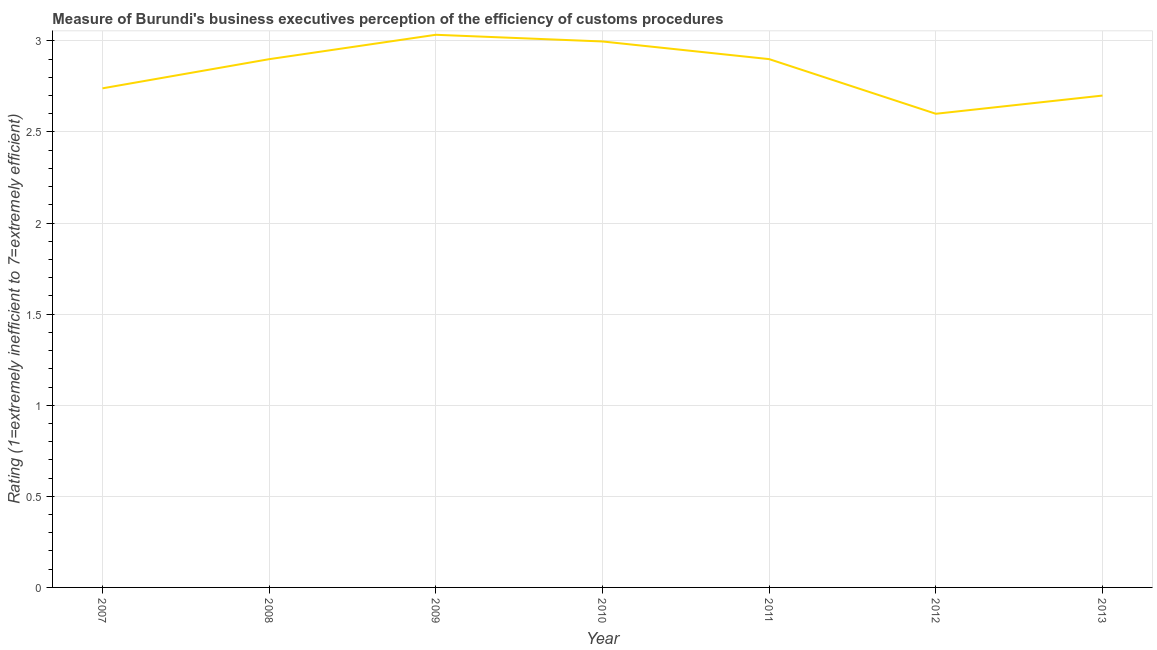Across all years, what is the maximum rating measuring burden of customs procedure?
Your response must be concise. 3.03. In which year was the rating measuring burden of customs procedure maximum?
Give a very brief answer. 2009. In which year was the rating measuring burden of customs procedure minimum?
Give a very brief answer. 2012. What is the sum of the rating measuring burden of customs procedure?
Provide a short and direct response. 19.87. What is the difference between the rating measuring burden of customs procedure in 2010 and 2012?
Ensure brevity in your answer.  0.4. What is the average rating measuring burden of customs procedure per year?
Ensure brevity in your answer.  2.84. What is the median rating measuring burden of customs procedure?
Offer a terse response. 2.9. In how many years, is the rating measuring burden of customs procedure greater than 1.7 ?
Make the answer very short. 7. What is the ratio of the rating measuring burden of customs procedure in 2011 to that in 2013?
Keep it short and to the point. 1.07. Is the difference between the rating measuring burden of customs procedure in 2009 and 2012 greater than the difference between any two years?
Provide a short and direct response. Yes. What is the difference between the highest and the second highest rating measuring burden of customs procedure?
Give a very brief answer. 0.04. Is the sum of the rating measuring burden of customs procedure in 2011 and 2012 greater than the maximum rating measuring burden of customs procedure across all years?
Your answer should be compact. Yes. What is the difference between the highest and the lowest rating measuring burden of customs procedure?
Your response must be concise. 0.43. In how many years, is the rating measuring burden of customs procedure greater than the average rating measuring burden of customs procedure taken over all years?
Keep it short and to the point. 4. How many lines are there?
Your answer should be very brief. 1. What is the difference between two consecutive major ticks on the Y-axis?
Your answer should be compact. 0.5. Does the graph contain any zero values?
Ensure brevity in your answer.  No. What is the title of the graph?
Your answer should be compact. Measure of Burundi's business executives perception of the efficiency of customs procedures. What is the label or title of the X-axis?
Keep it short and to the point. Year. What is the label or title of the Y-axis?
Provide a succinct answer. Rating (1=extremely inefficient to 7=extremely efficient). What is the Rating (1=extremely inefficient to 7=extremely efficient) in 2007?
Your answer should be very brief. 2.74. What is the Rating (1=extremely inefficient to 7=extremely efficient) of 2008?
Offer a very short reply. 2.9. What is the Rating (1=extremely inefficient to 7=extremely efficient) of 2009?
Provide a short and direct response. 3.03. What is the Rating (1=extremely inefficient to 7=extremely efficient) in 2010?
Give a very brief answer. 3. What is the Rating (1=extremely inefficient to 7=extremely efficient) in 2012?
Ensure brevity in your answer.  2.6. What is the Rating (1=extremely inefficient to 7=extremely efficient) of 2013?
Your answer should be very brief. 2.7. What is the difference between the Rating (1=extremely inefficient to 7=extremely efficient) in 2007 and 2008?
Make the answer very short. -0.16. What is the difference between the Rating (1=extremely inefficient to 7=extremely efficient) in 2007 and 2009?
Keep it short and to the point. -0.29. What is the difference between the Rating (1=extremely inefficient to 7=extremely efficient) in 2007 and 2010?
Offer a terse response. -0.26. What is the difference between the Rating (1=extremely inefficient to 7=extremely efficient) in 2007 and 2011?
Ensure brevity in your answer.  -0.16. What is the difference between the Rating (1=extremely inefficient to 7=extremely efficient) in 2007 and 2012?
Offer a very short reply. 0.14. What is the difference between the Rating (1=extremely inefficient to 7=extremely efficient) in 2007 and 2013?
Offer a very short reply. 0.04. What is the difference between the Rating (1=extremely inefficient to 7=extremely efficient) in 2008 and 2009?
Your answer should be very brief. -0.13. What is the difference between the Rating (1=extremely inefficient to 7=extremely efficient) in 2008 and 2010?
Your answer should be compact. -0.1. What is the difference between the Rating (1=extremely inefficient to 7=extremely efficient) in 2008 and 2011?
Give a very brief answer. -0. What is the difference between the Rating (1=extremely inefficient to 7=extremely efficient) in 2008 and 2012?
Your response must be concise. 0.3. What is the difference between the Rating (1=extremely inefficient to 7=extremely efficient) in 2008 and 2013?
Offer a very short reply. 0.2. What is the difference between the Rating (1=extremely inefficient to 7=extremely efficient) in 2009 and 2010?
Offer a very short reply. 0.04. What is the difference between the Rating (1=extremely inefficient to 7=extremely efficient) in 2009 and 2011?
Your answer should be very brief. 0.13. What is the difference between the Rating (1=extremely inefficient to 7=extremely efficient) in 2009 and 2012?
Your answer should be compact. 0.43. What is the difference between the Rating (1=extremely inefficient to 7=extremely efficient) in 2009 and 2013?
Keep it short and to the point. 0.33. What is the difference between the Rating (1=extremely inefficient to 7=extremely efficient) in 2010 and 2011?
Make the answer very short. 0.1. What is the difference between the Rating (1=extremely inefficient to 7=extremely efficient) in 2010 and 2012?
Provide a short and direct response. 0.4. What is the difference between the Rating (1=extremely inefficient to 7=extremely efficient) in 2010 and 2013?
Ensure brevity in your answer.  0.3. What is the difference between the Rating (1=extremely inefficient to 7=extremely efficient) in 2011 and 2013?
Your answer should be very brief. 0.2. What is the difference between the Rating (1=extremely inefficient to 7=extremely efficient) in 2012 and 2013?
Keep it short and to the point. -0.1. What is the ratio of the Rating (1=extremely inefficient to 7=extremely efficient) in 2007 to that in 2008?
Your response must be concise. 0.94. What is the ratio of the Rating (1=extremely inefficient to 7=extremely efficient) in 2007 to that in 2009?
Your answer should be compact. 0.9. What is the ratio of the Rating (1=extremely inefficient to 7=extremely efficient) in 2007 to that in 2010?
Offer a terse response. 0.91. What is the ratio of the Rating (1=extremely inefficient to 7=extremely efficient) in 2007 to that in 2011?
Your answer should be compact. 0.94. What is the ratio of the Rating (1=extremely inefficient to 7=extremely efficient) in 2007 to that in 2012?
Make the answer very short. 1.05. What is the ratio of the Rating (1=extremely inefficient to 7=extremely efficient) in 2008 to that in 2009?
Make the answer very short. 0.96. What is the ratio of the Rating (1=extremely inefficient to 7=extremely efficient) in 2008 to that in 2011?
Provide a short and direct response. 1. What is the ratio of the Rating (1=extremely inefficient to 7=extremely efficient) in 2008 to that in 2012?
Offer a very short reply. 1.11. What is the ratio of the Rating (1=extremely inefficient to 7=extremely efficient) in 2008 to that in 2013?
Offer a very short reply. 1.07. What is the ratio of the Rating (1=extremely inefficient to 7=extremely efficient) in 2009 to that in 2010?
Offer a terse response. 1.01. What is the ratio of the Rating (1=extremely inefficient to 7=extremely efficient) in 2009 to that in 2011?
Provide a short and direct response. 1.05. What is the ratio of the Rating (1=extremely inefficient to 7=extremely efficient) in 2009 to that in 2012?
Make the answer very short. 1.17. What is the ratio of the Rating (1=extremely inefficient to 7=extremely efficient) in 2009 to that in 2013?
Keep it short and to the point. 1.12. What is the ratio of the Rating (1=extremely inefficient to 7=extremely efficient) in 2010 to that in 2011?
Ensure brevity in your answer.  1.03. What is the ratio of the Rating (1=extremely inefficient to 7=extremely efficient) in 2010 to that in 2012?
Offer a terse response. 1.15. What is the ratio of the Rating (1=extremely inefficient to 7=extremely efficient) in 2010 to that in 2013?
Offer a very short reply. 1.11. What is the ratio of the Rating (1=extremely inefficient to 7=extremely efficient) in 2011 to that in 2012?
Give a very brief answer. 1.11. What is the ratio of the Rating (1=extremely inefficient to 7=extremely efficient) in 2011 to that in 2013?
Your answer should be very brief. 1.07. What is the ratio of the Rating (1=extremely inefficient to 7=extremely efficient) in 2012 to that in 2013?
Ensure brevity in your answer.  0.96. 